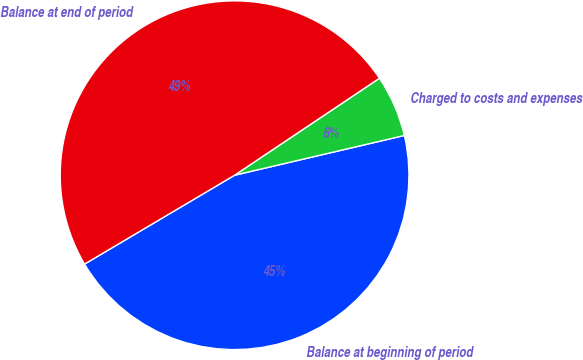Convert chart. <chart><loc_0><loc_0><loc_500><loc_500><pie_chart><fcel>Balance at beginning of period<fcel>Charged to costs and expenses<fcel>Balance at end of period<nl><fcel>45.15%<fcel>5.73%<fcel>49.12%<nl></chart> 